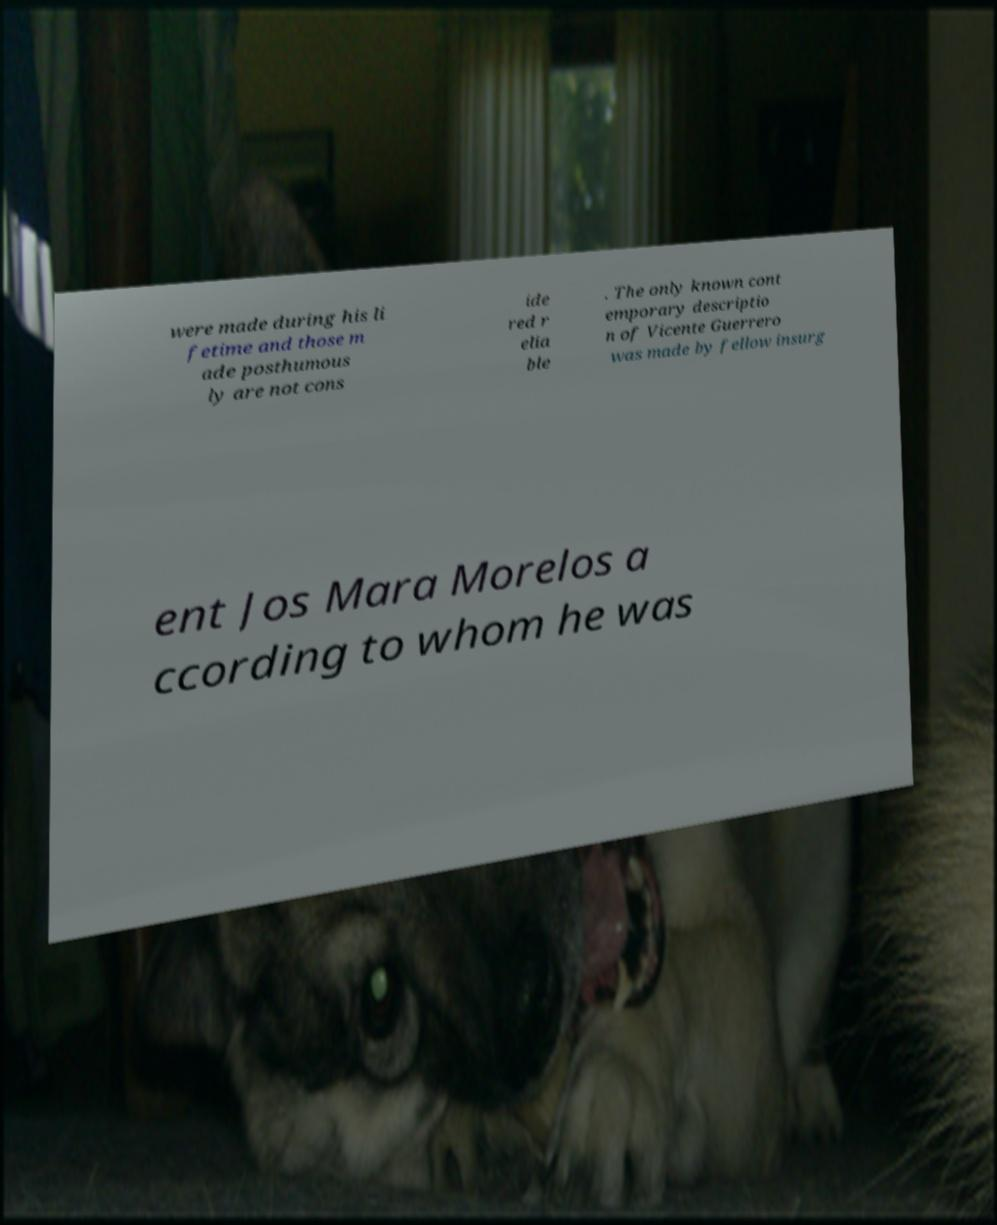I need the written content from this picture converted into text. Can you do that? were made during his li fetime and those m ade posthumous ly are not cons ide red r elia ble . The only known cont emporary descriptio n of Vicente Guerrero was made by fellow insurg ent Jos Mara Morelos a ccording to whom he was 